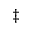<formula> <loc_0><loc_0><loc_500><loc_500>\ddagger</formula> 